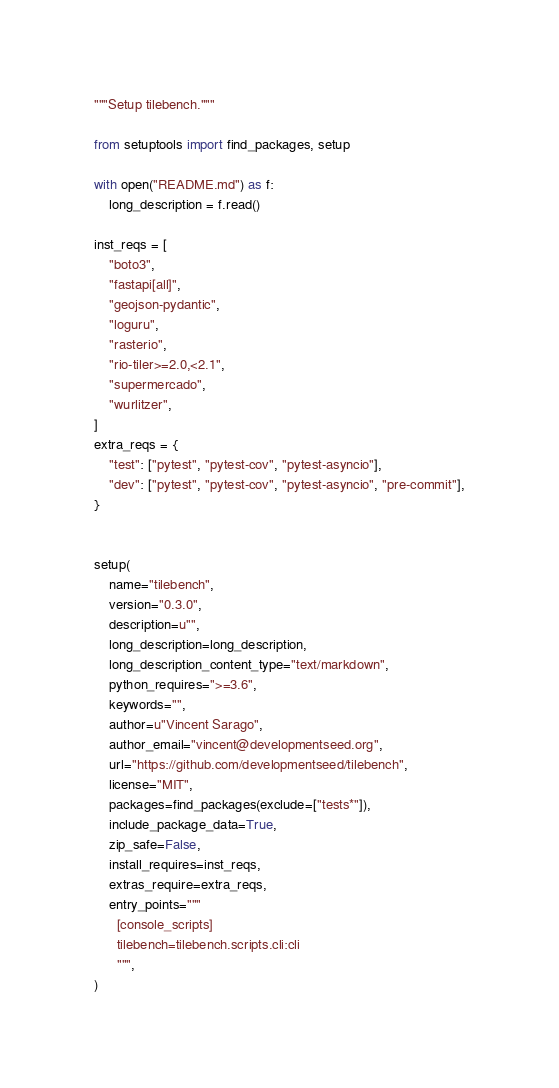Convert code to text. <code><loc_0><loc_0><loc_500><loc_500><_Python_>"""Setup tilebench."""

from setuptools import find_packages, setup

with open("README.md") as f:
    long_description = f.read()

inst_reqs = [
    "boto3",
    "fastapi[all]",
    "geojson-pydantic",
    "loguru",
    "rasterio",
    "rio-tiler>=2.0,<2.1",
    "supermercado",
    "wurlitzer",
]
extra_reqs = {
    "test": ["pytest", "pytest-cov", "pytest-asyncio"],
    "dev": ["pytest", "pytest-cov", "pytest-asyncio", "pre-commit"],
}


setup(
    name="tilebench",
    version="0.3.0",
    description=u"",
    long_description=long_description,
    long_description_content_type="text/markdown",
    python_requires=">=3.6",
    keywords="",
    author=u"Vincent Sarago",
    author_email="vincent@developmentseed.org",
    url="https://github.com/developmentseed/tilebench",
    license="MIT",
    packages=find_packages(exclude=["tests*"]),
    include_package_data=True,
    zip_safe=False,
    install_requires=inst_reqs,
    extras_require=extra_reqs,
    entry_points="""
      [console_scripts]
      tilebench=tilebench.scripts.cli:cli
      """,
)
</code> 